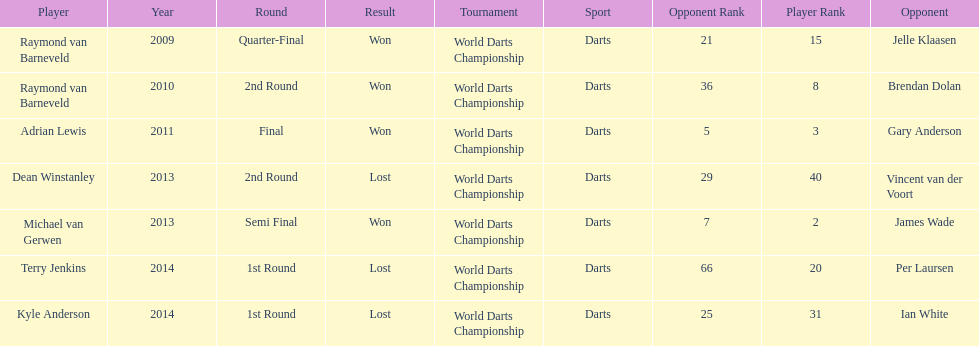Is dean winstanley listed above or below kyle anderson? Above. 